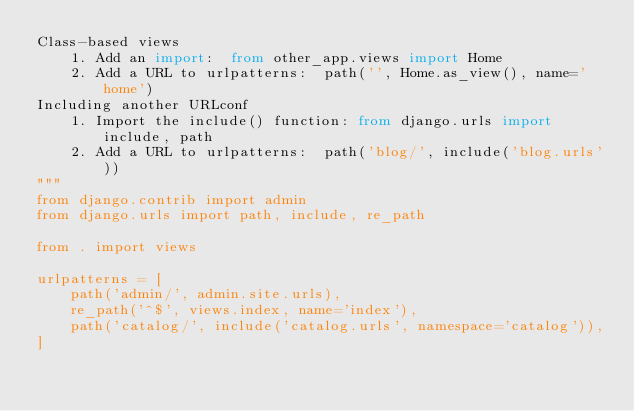Convert code to text. <code><loc_0><loc_0><loc_500><loc_500><_Python_>Class-based views
    1. Add an import:  from other_app.views import Home
    2. Add a URL to urlpatterns:  path('', Home.as_view(), name='home')
Including another URLconf
    1. Import the include() function: from django.urls import include, path
    2. Add a URL to urlpatterns:  path('blog/', include('blog.urls'))
"""
from django.contrib import admin
from django.urls import path, include, re_path

from . import views

urlpatterns = [
    path('admin/', admin.site.urls),
    re_path('^$', views.index, name='index'),
    path('catalog/', include('catalog.urls', namespace='catalog')),
]
</code> 